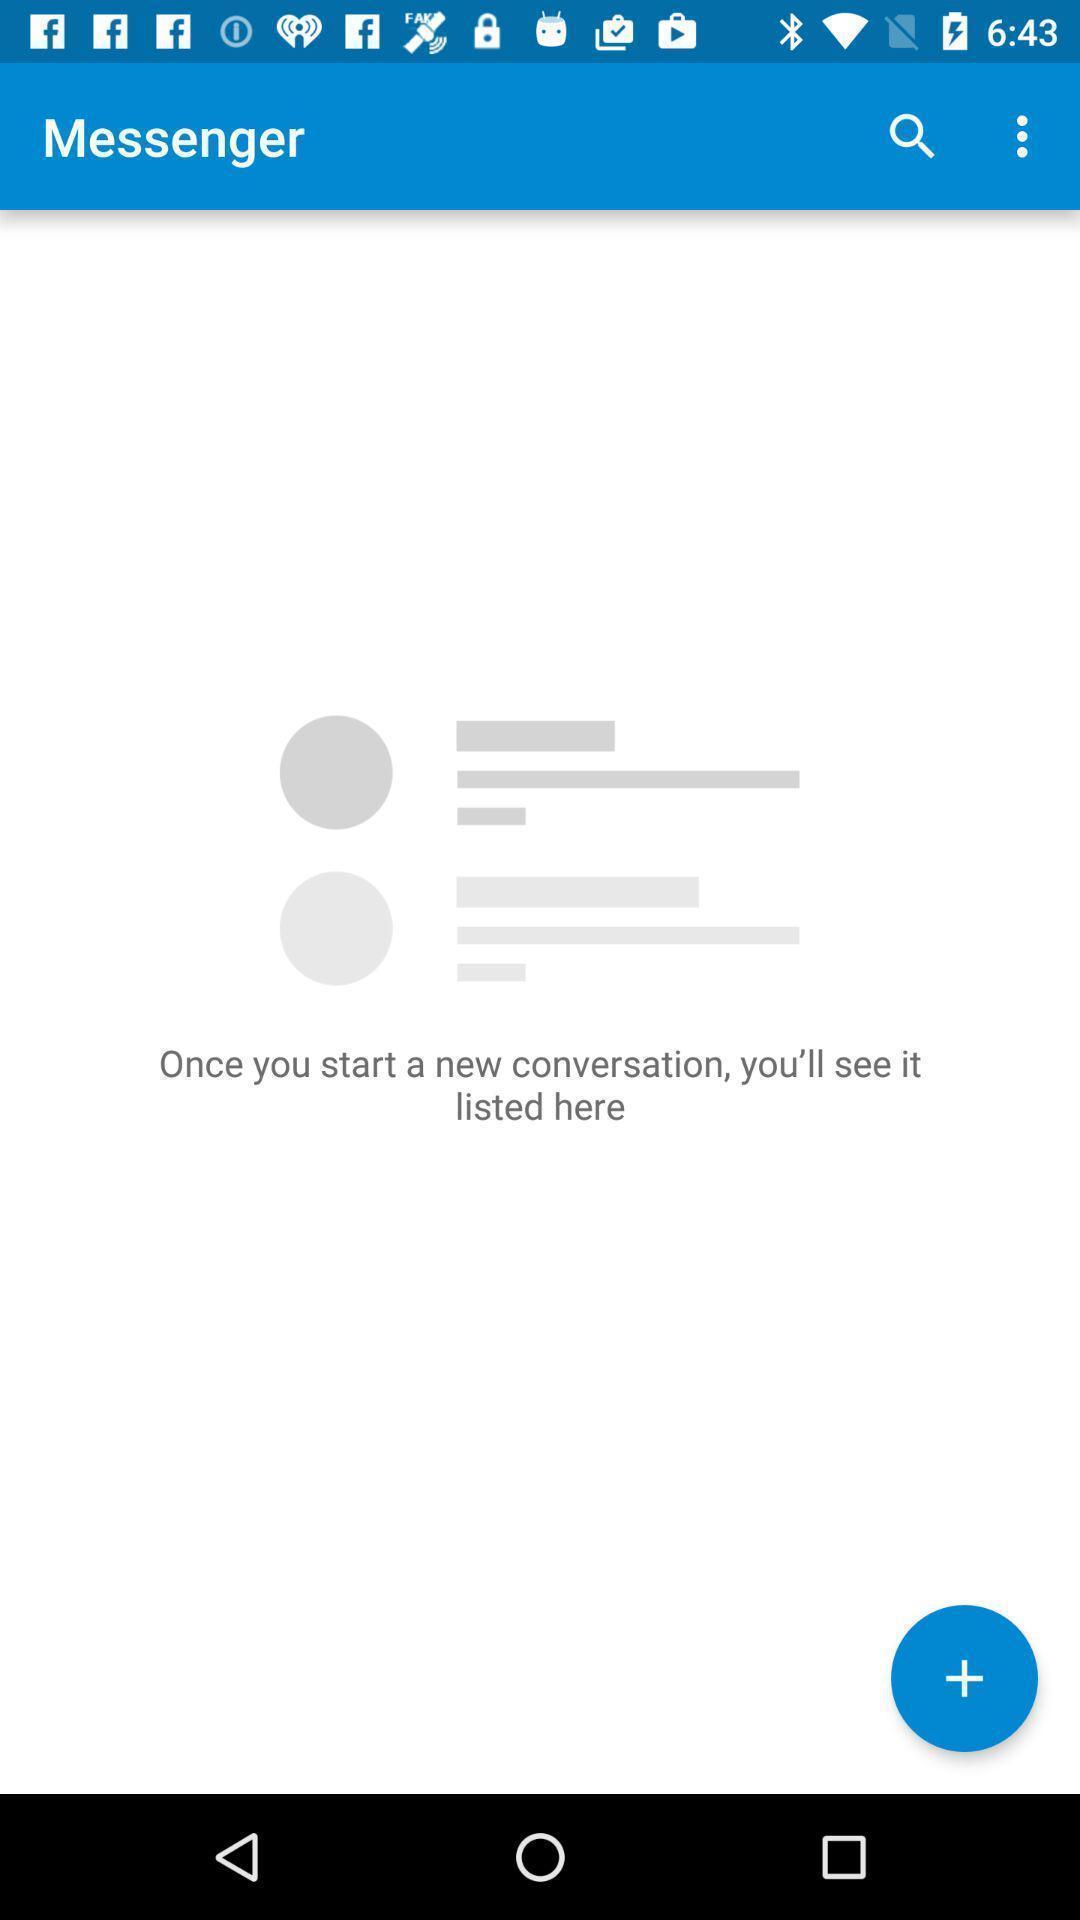Give me a summary of this screen capture. Screen displaying the page of a social app. 